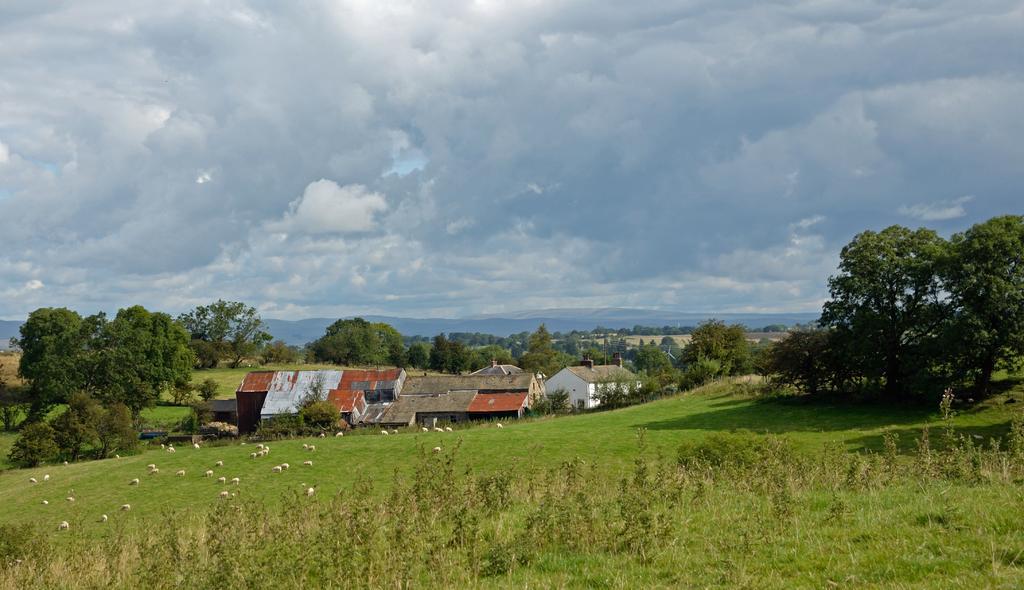In one or two sentences, can you explain what this image depicts? In this image I can see the plants and few animals on the ground. In the background I can see the houses, many trees and the mountains. I can see the clouds and the sky in the back. 